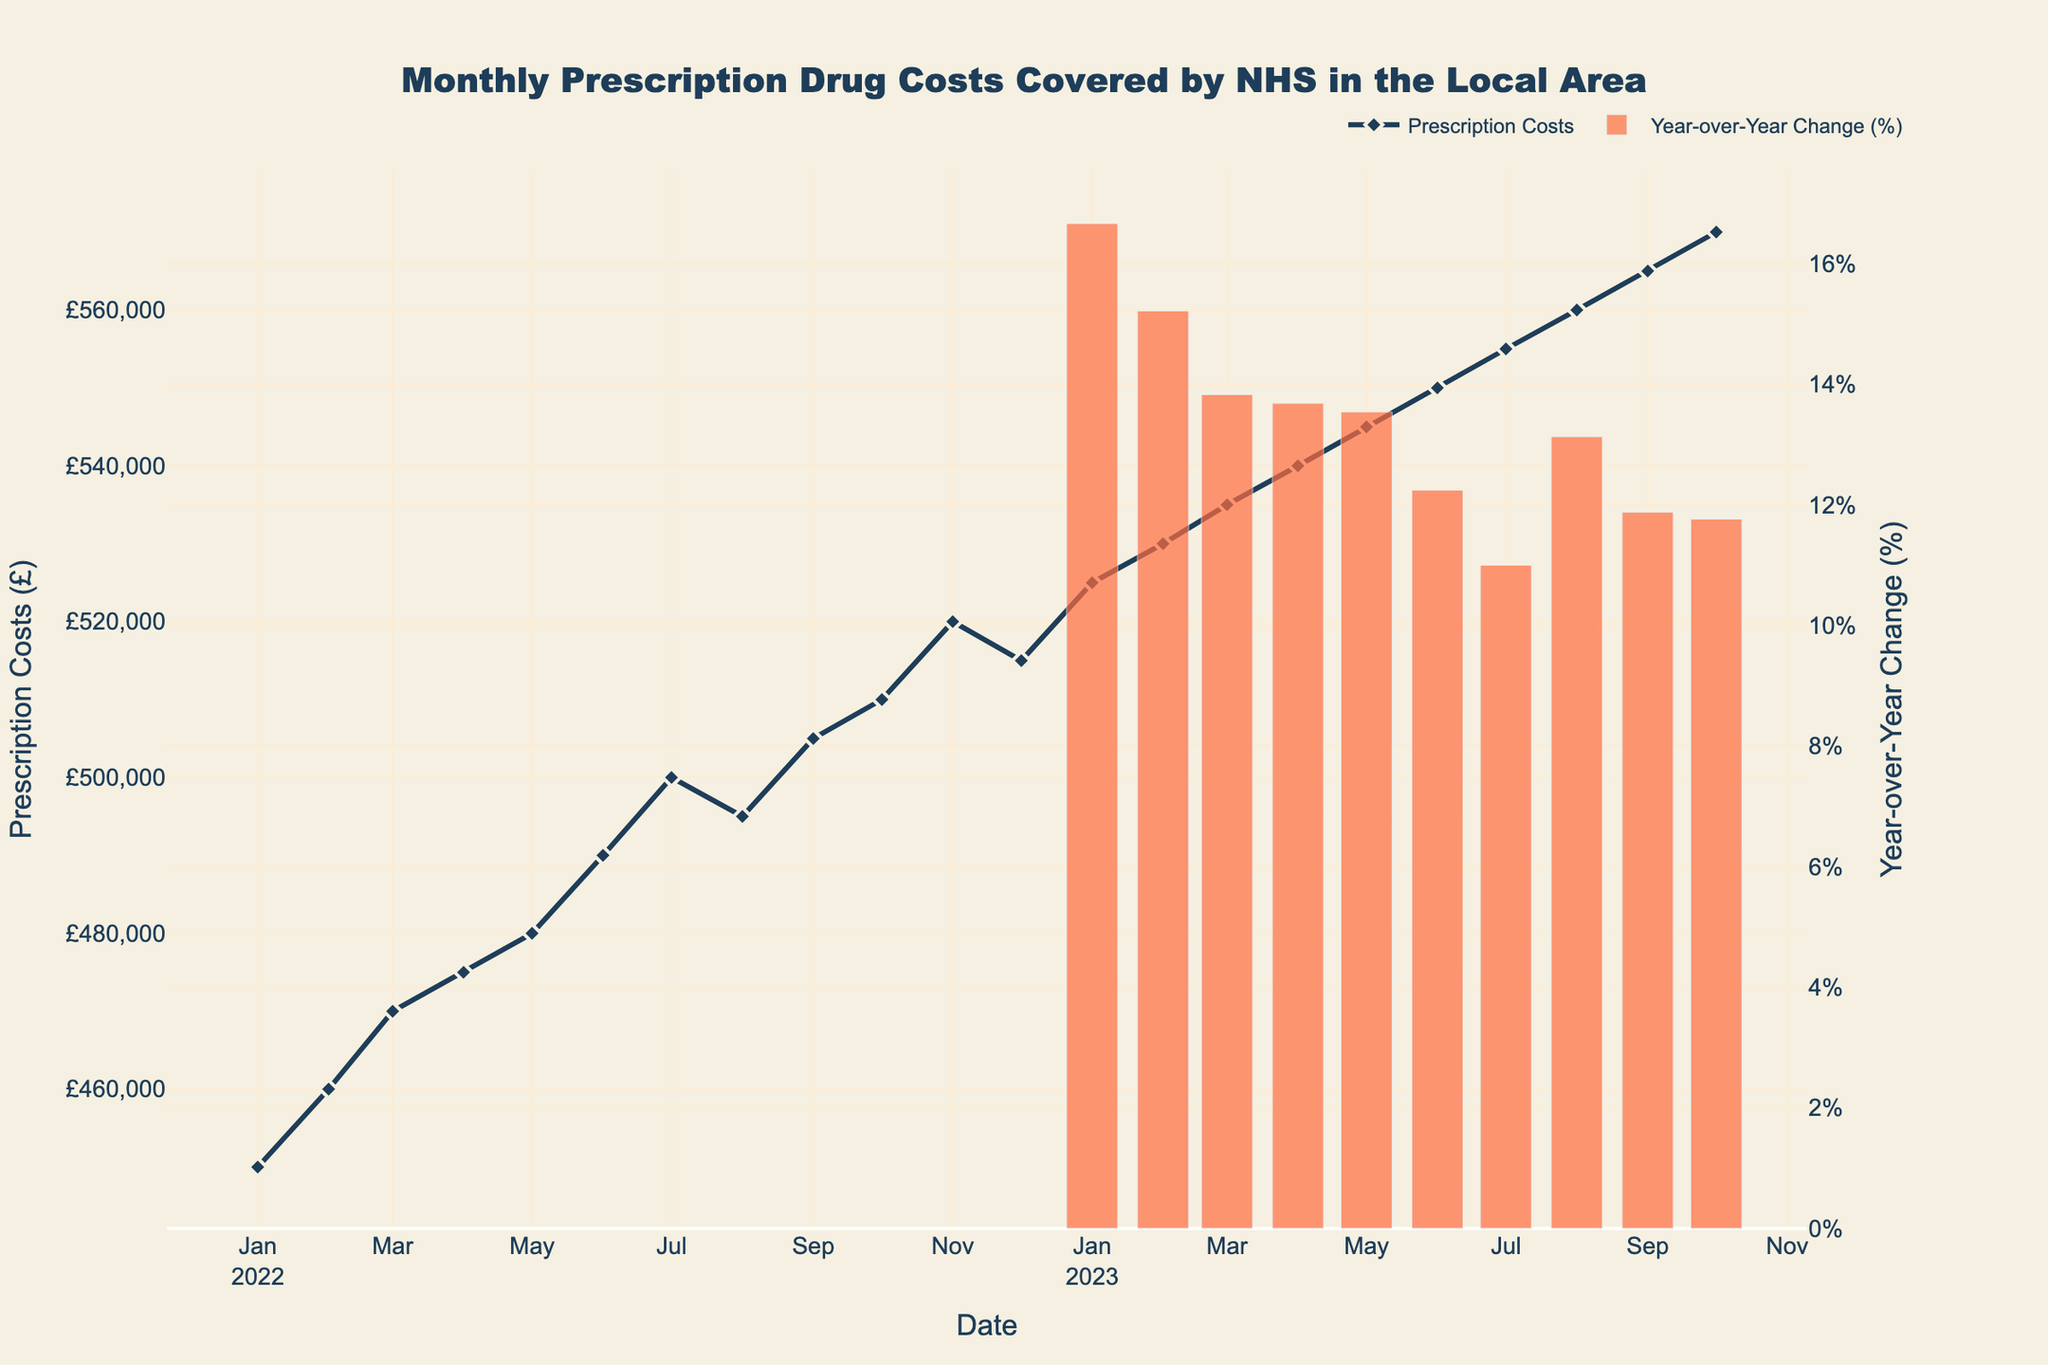What's the title of the figure? The title is provided at the top of the plot and is visually prominent.
Answer: Monthly Prescription Drug Costs Covered by NHS in the Local Area What is the y-axis title for the primary y-axis? The primary y-axis is labeled on the left side of the plot and represents the prescription costs in pounds.
Answer: Prescription Costs (£) What is the y-axis title for the secondary y-axis? The secondary y-axis is labeled on the right side of the plot and represents the year-over-year change as a percentage.
Answer: Year-over-Year Change (%) What pattern do you observe in the prescription costs from January 2022 to October 2023? By visually following the plotted line, we observe that the prescription costs have generally increased over the period from January 2022 to October 2023.
Answer: Increasing In which month did the prescription costs reach their highest value? By identifying the peak point on the primary y-axis, we see that the highest value is in October 2023.
Answer: October 2023 What was the prescription cost in July 2022? Locate July 2022 on the x-axis and then follow the point to the primary y-axis.
Answer: £500,000 How did the prescription costs in February 2023 compare to February 2022? Locate both points on the x-axis (February 2022 and February 2023) and compare their positions on the primary y-axis. February 2023 is higher.
Answer: February 2023 is higher Calculate the average prescription costs for the year 2022. Sum the monthly prescription costs for 2022 and divide by 12: (450000 + 460000 + 470000 + 475000 + 480000 + 490000 + 500000 + 495000 + 505000 + 510000 + 520000 + 515000) / 12.
Answer: £488,750 What is the trend in the year-over-year change (%)? By following the bars plotted on the secondary y-axis, we notice that the year-over-year change in costs has generally been positive and increasing.
Answer: Increasing positive trend During which month did we see the highest year-over-year change? Identify the tallest bar on the secondary y-axis to find the month with the highest year-over-year change.
Answer: October 2023 